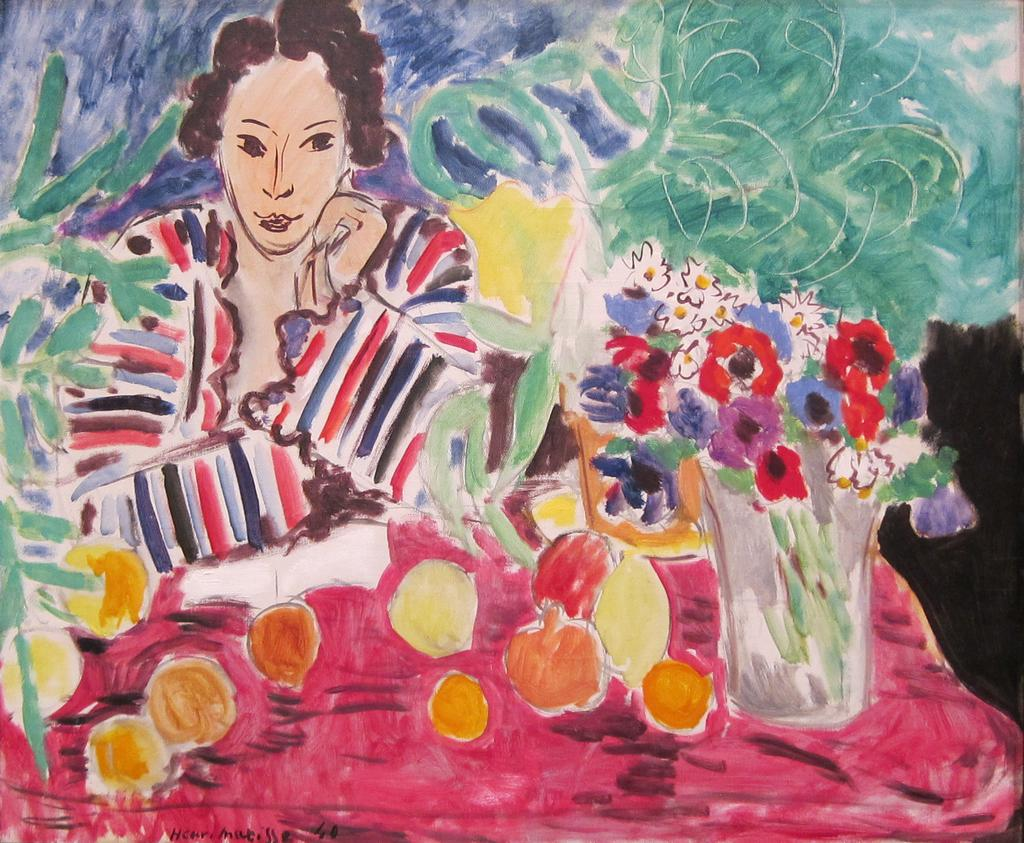What is depicted in the painting in the image? There is a painting of a person in the image. What other items can be seen in the image besides the painting? There are fruits, flowers, and plants in the image. What type of net is being used to catch the judge in the image? There is no net or judge present in the image; it features a painting of a person, fruits, flowers, and plants. 